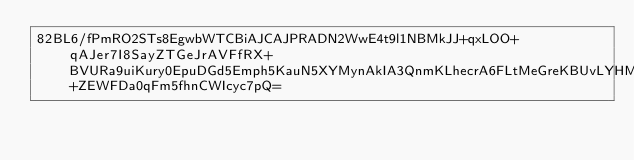Convert code to text. <code><loc_0><loc_0><loc_500><loc_500><_SML_>82BL6/fPmRO2STs8EgwbWTCBiAJCAJPRADN2WwE4t9l1NBMkJJ+qxLOO+qAJer7I8SayZTGeJrAVFfRX+BVURa9uiKury0EpuDGd5Emph5KauN5XYMynAkIA3QnmKLhecrA6FLtMeGreKBUvLYHMo77BXHwEwrSOge8WXmVmi2rfqIeguddWA3H+ZEWFDa0qFm5fhnCWIcyc7pQ=</code> 